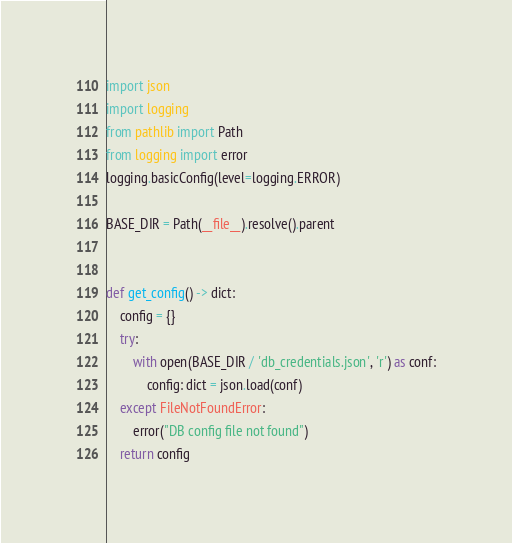<code> <loc_0><loc_0><loc_500><loc_500><_Python_>import json
import logging
from pathlib import Path
from logging import error
logging.basicConfig(level=logging.ERROR)

BASE_DIR = Path(__file__).resolve().parent


def get_config() -> dict:
    config = {}
    try:
        with open(BASE_DIR / 'db_credentials.json', 'r') as conf:
            config: dict = json.load(conf)
    except FileNotFoundError:
        error("DB config file not found")
    return config
</code> 